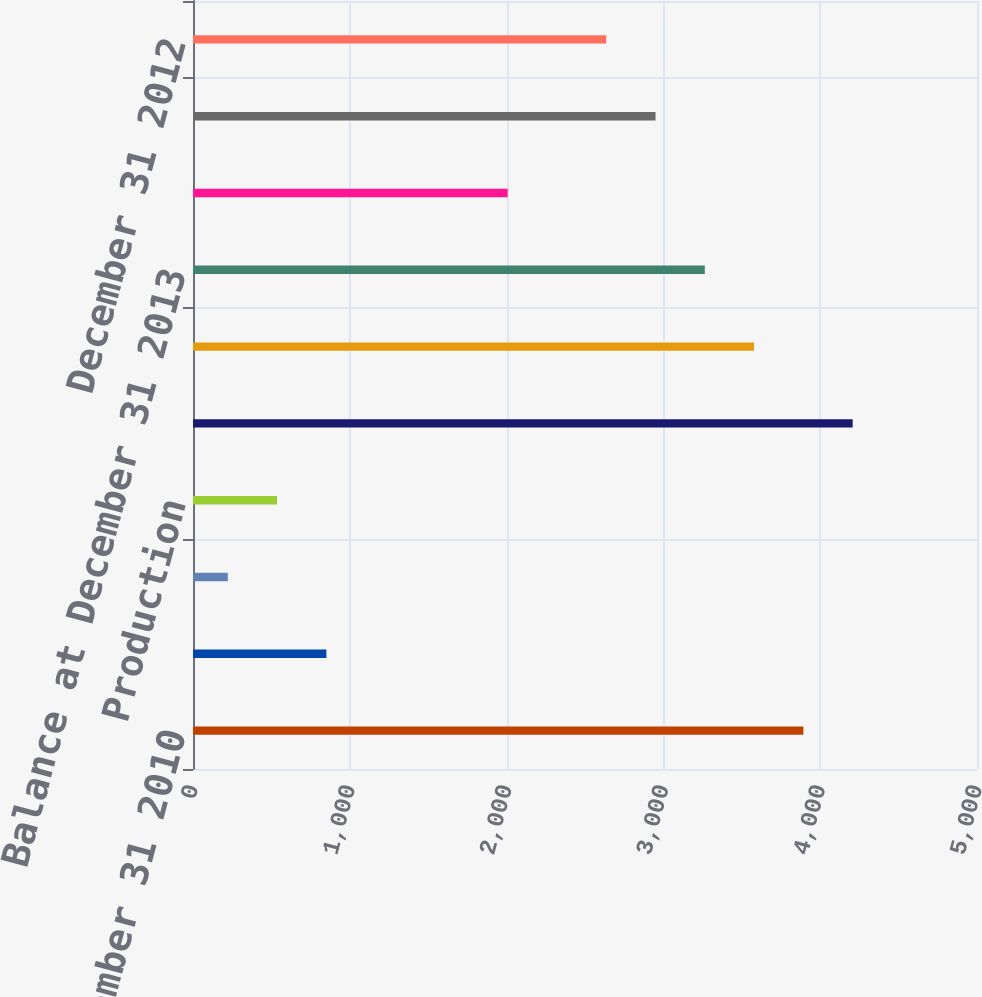Convert chart to OTSL. <chart><loc_0><loc_0><loc_500><loc_500><bar_chart><fcel>Balance at December 31 2010<fcel>Revisions of previous<fcel>Improved recovery<fcel>Production<fcel>Balance at December 31 2011<fcel>Balance at December 31 2012<fcel>Balance at December 31 2013<fcel>December 31 2010<fcel>December 31 2011<fcel>December 31 2012<nl><fcel>3892.8<fcel>850.6<fcel>222<fcel>536.3<fcel>4207.1<fcel>3578.5<fcel>3264.2<fcel>2007<fcel>2949.9<fcel>2635.6<nl></chart> 